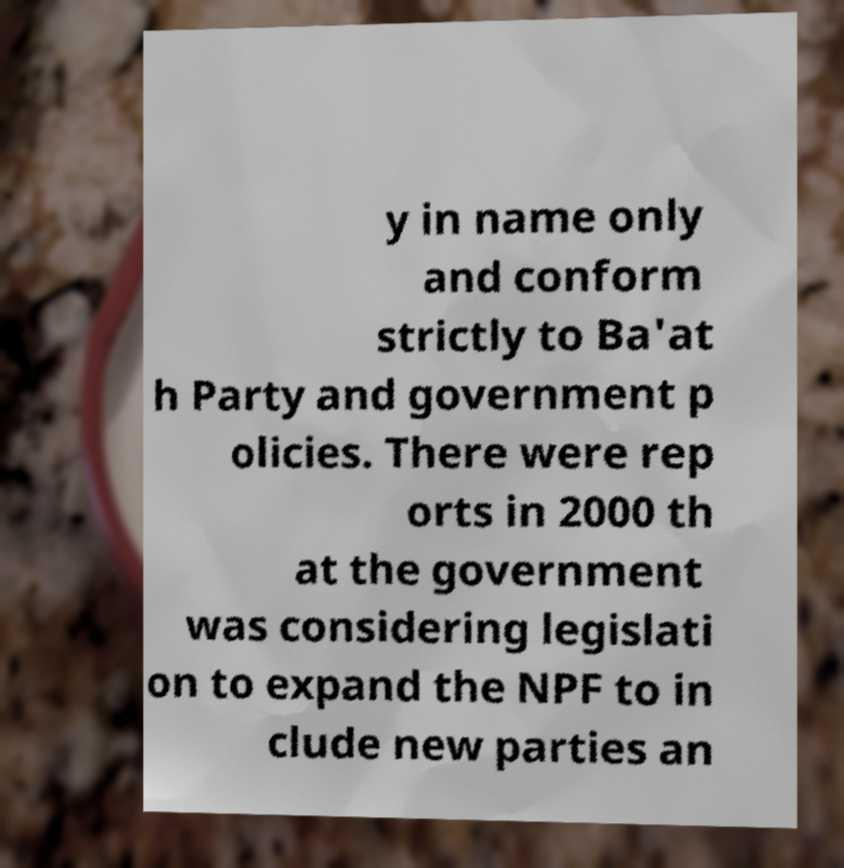Please read and relay the text visible in this image. What does it say? y in name only and conform strictly to Ba'at h Party and government p olicies. There were rep orts in 2000 th at the government was considering legislati on to expand the NPF to in clude new parties an 